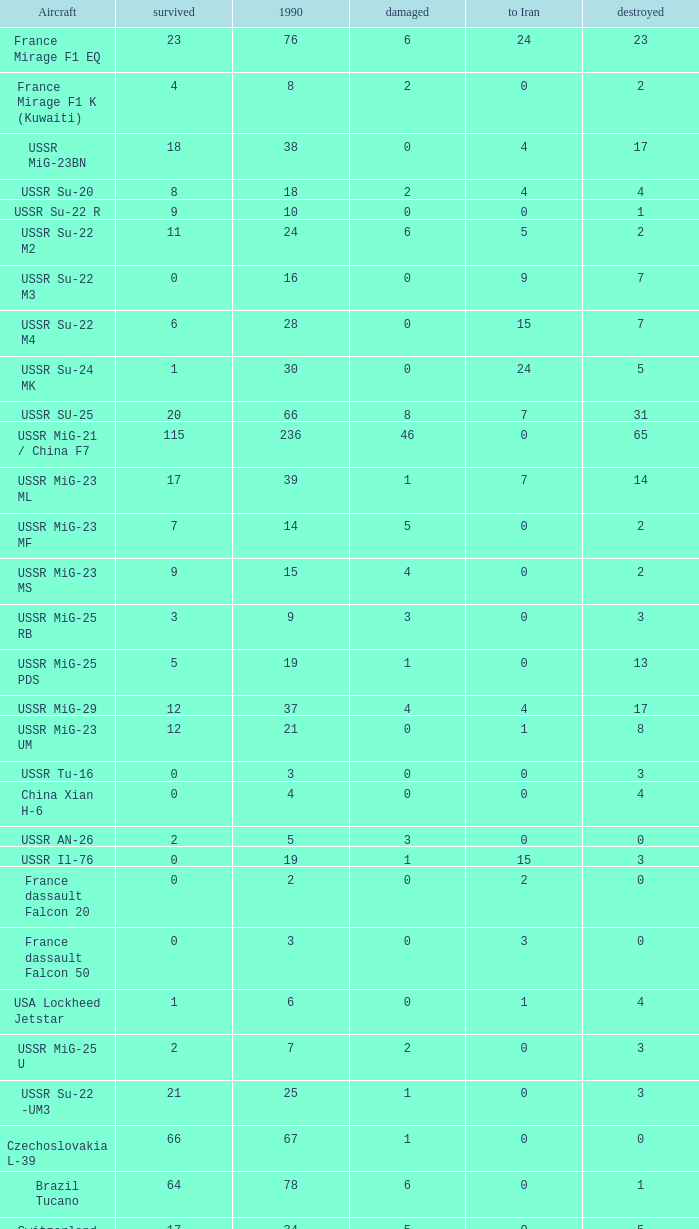If there were 14 in 1990 and 6 survived how many were destroyed? 1.0. 